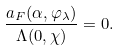Convert formula to latex. <formula><loc_0><loc_0><loc_500><loc_500>\frac { a _ { F } ( \alpha , \varphi _ { \lambda } ) } { \Lambda ( 0 , \chi ) } = 0 .</formula> 